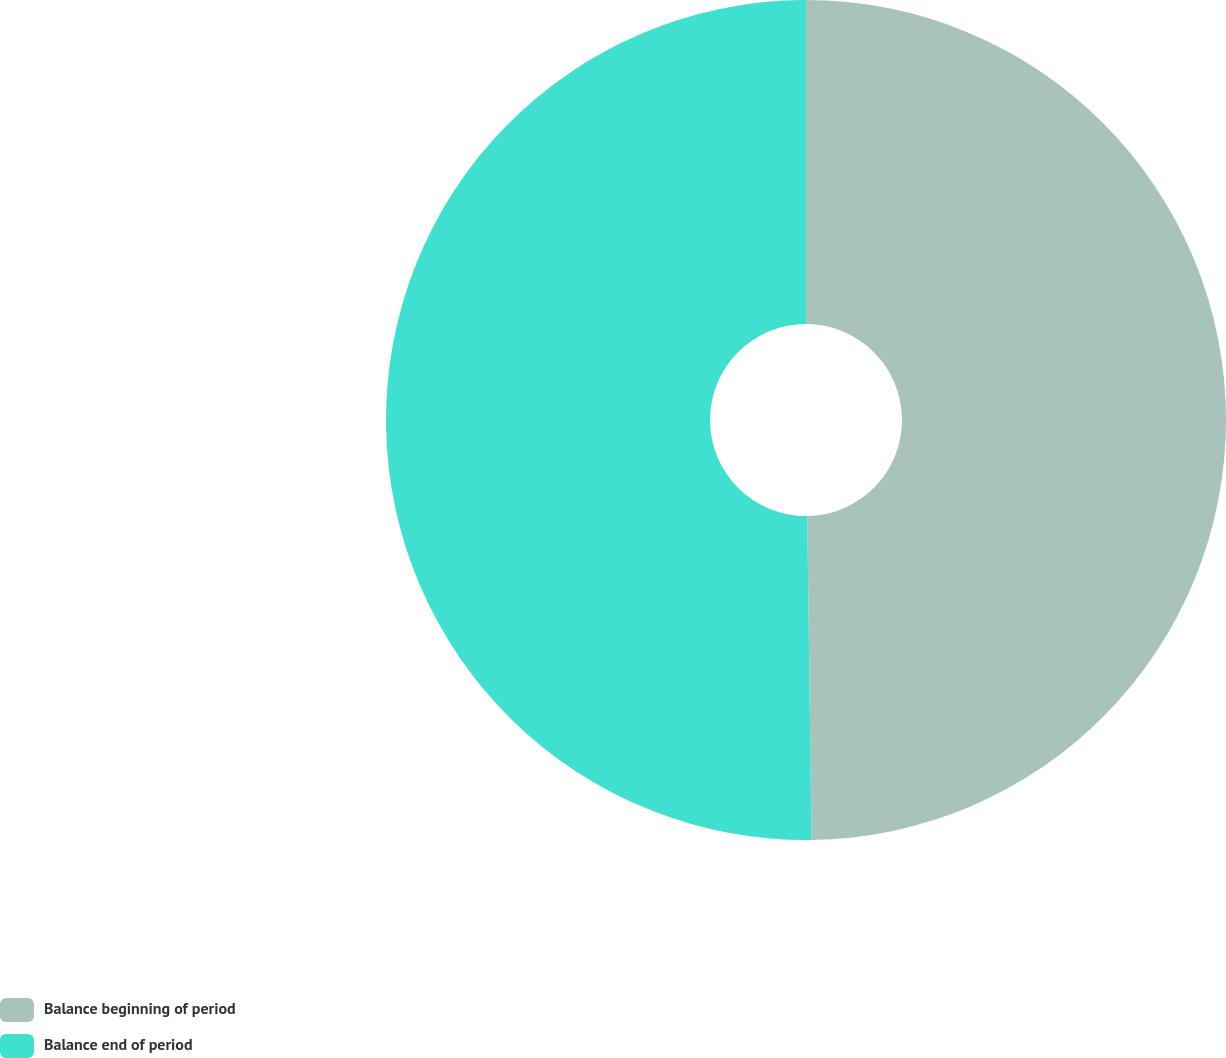<chart> <loc_0><loc_0><loc_500><loc_500><pie_chart><fcel>Balance beginning of period<fcel>Balance end of period<nl><fcel>49.79%<fcel>50.21%<nl></chart> 